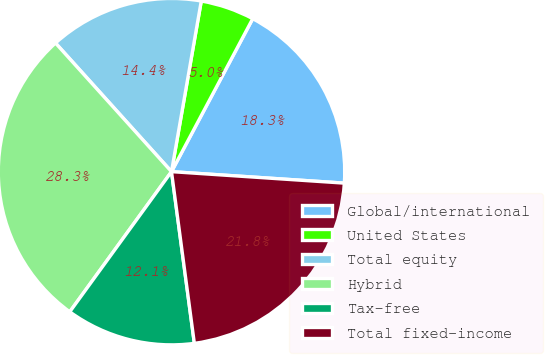Convert chart to OTSL. <chart><loc_0><loc_0><loc_500><loc_500><pie_chart><fcel>Global/international<fcel>United States<fcel>Total equity<fcel>Hybrid<fcel>Tax-free<fcel>Total fixed-income<nl><fcel>18.29%<fcel>5.02%<fcel>14.43%<fcel>28.33%<fcel>12.1%<fcel>21.84%<nl></chart> 